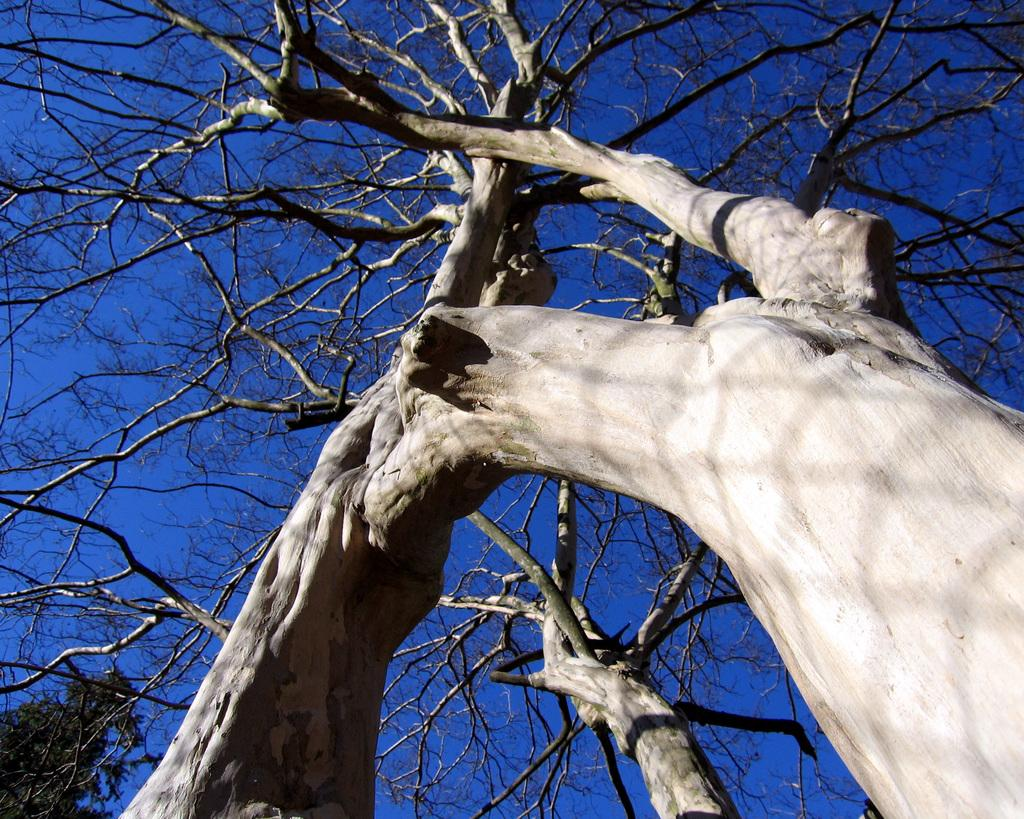What is located in the foreground of the image? There is a tree in the foreground of the image. What can be seen in the background of the image? The sky is visible in the image. At what time of day was the image taken? The image was taken during the evening. What type of seed is being used to tie the knot in the trousers in the image? There are no seeds, knots, or trousers present in the image. 